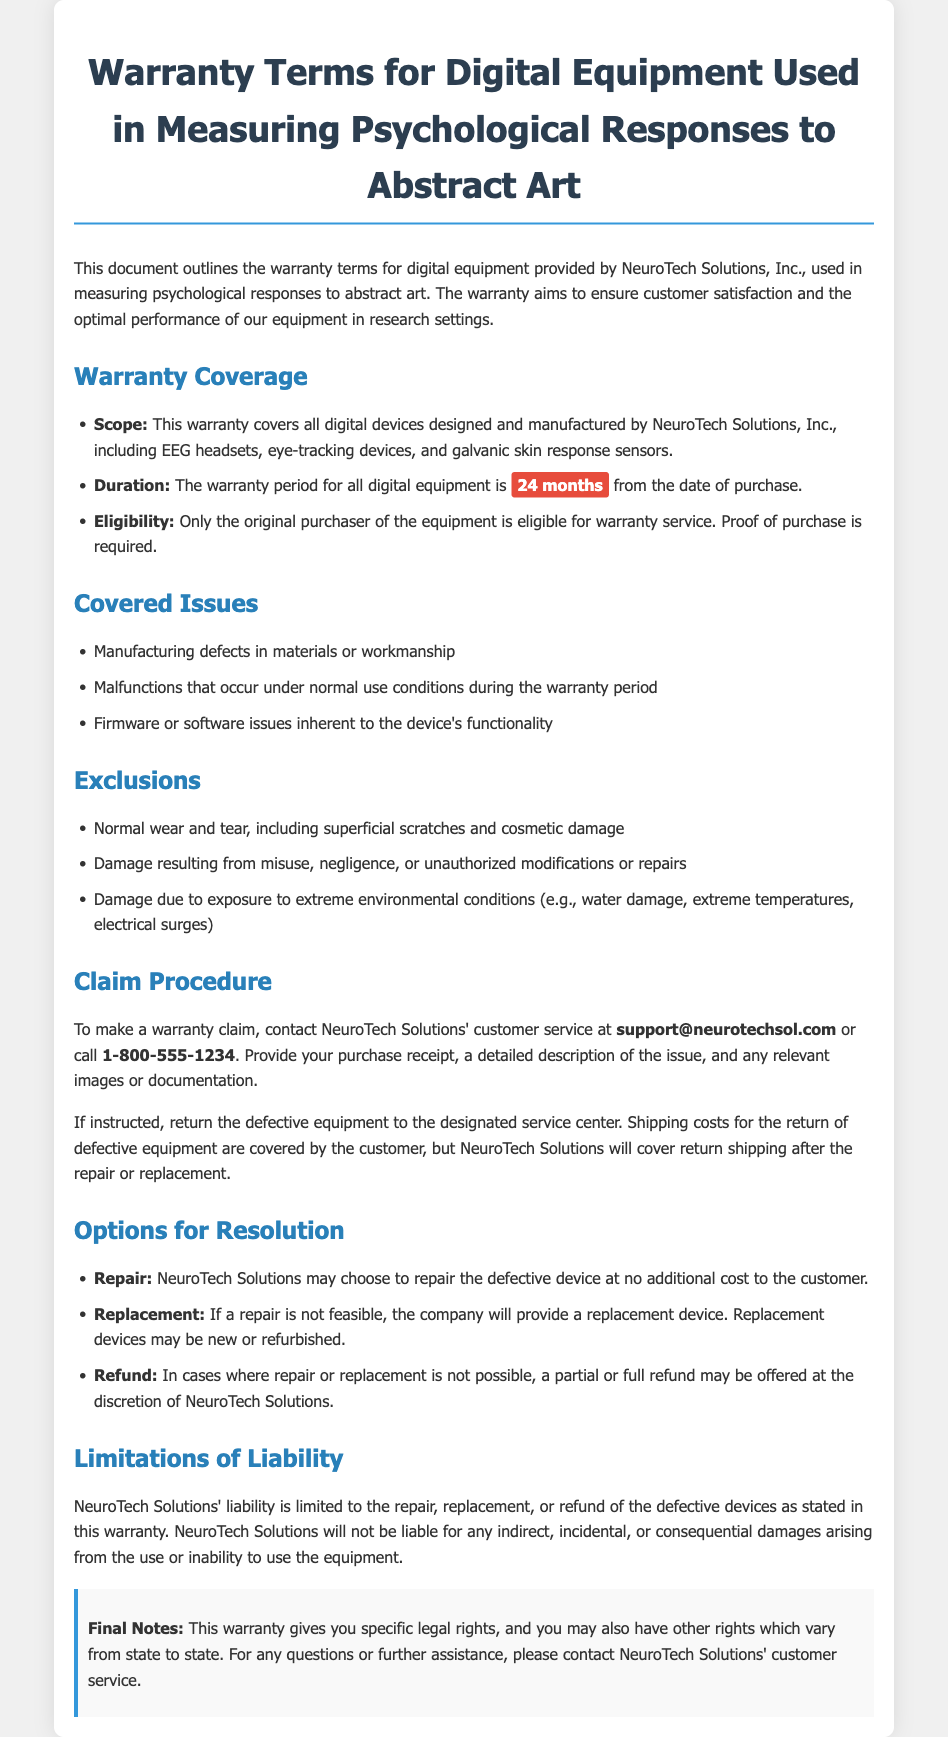What is the warranty period for the digital equipment? The warranty period for all digital equipment is stated clearly in the document as lasting for a specific duration of time.
Answer: 24 months Who is eligible for warranty service? The document specifies who is entitled to receive warranty service, which includes certain details about the purchaser.
Answer: Original purchaser What types of devices are covered under this warranty? The document includes a list of specific devices that are covered, providing clarity on the scope of the warranty.
Answer: EEG headsets, eye-tracking devices, galvanic skin response sensors What must be provided to make a warranty claim? The document outlines essential requirements for initiating a warranty claim, emphasizing specific documentation needed.
Answer: Purchase receipt What actions are excluded from the warranty coverage? The document details the limitations of the warranty, indicating actions that would not qualify for coverage under normal circumstances.
Answer: Misuse, negligence What options are available for resolution of warranty claims? The document describes possible resolutions for claims, which indicates what actions may be taken if the equipment is found to be defective.
Answer: Repair, Replacement, Refund How can a customer contact for warranty claims? The document provides specific contact information for customer service regarding warranty inquiries, making it easy for users to reach out for help.
Answer: support@neurotechsol.com Is there any liability beyond the warranty terms? The document addresses the company's liability, indicating limitations regarding additional repercussions related to the warranty.
Answer: Limited to repair, replacement, or refund 